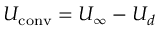<formula> <loc_0><loc_0><loc_500><loc_500>U _ { c o n v } = U _ { \infty } - U _ { d }</formula> 